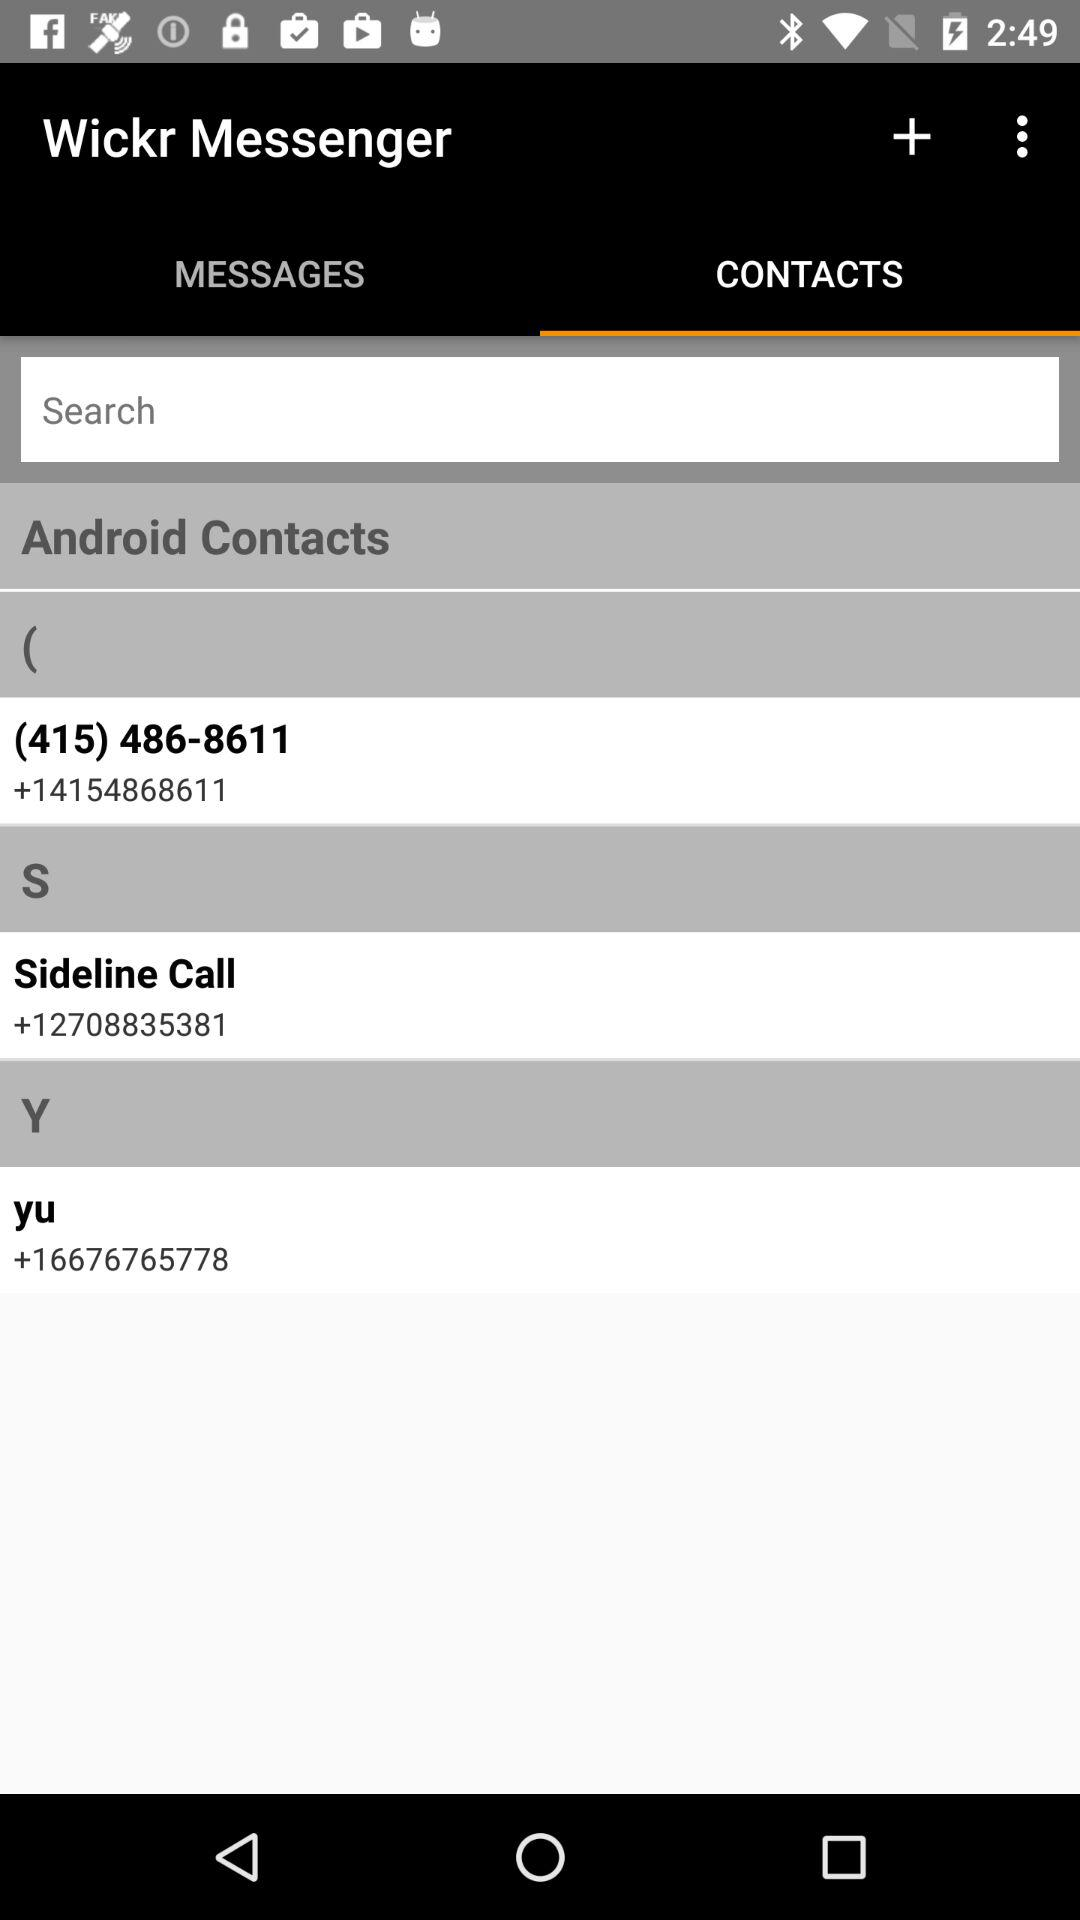What is the app title? The app title is "Wickr Messenger". 